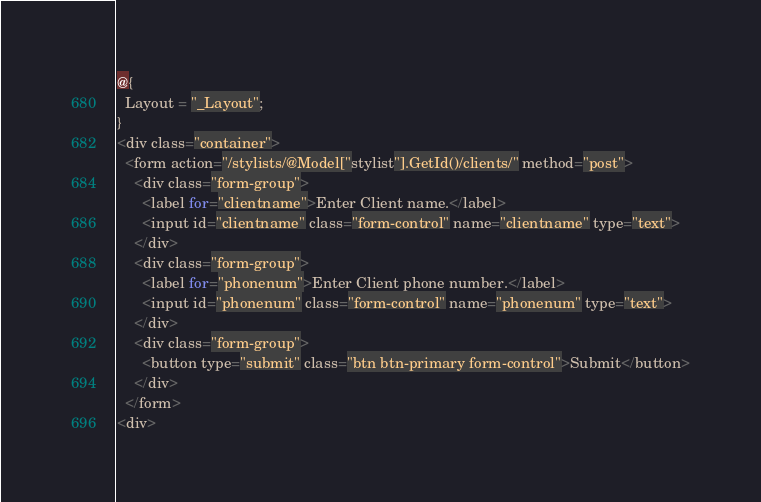<code> <loc_0><loc_0><loc_500><loc_500><_C#_>@{
  Layout = "_Layout";
}
<div class="container">
  <form action="/stylists/@Model["stylist"].GetId()/clients/" method="post">
    <div class="form-group">
      <label for="clientname">Enter Client name.</label>
      <input id="clientname" class="form-control" name="clientname" type="text">
    </div>
    <div class="form-group">
      <label for="phonenum">Enter Client phone number.</label>
      <input id="phonenum" class="form-control" name="phonenum" type="text">
    </div>
    <div class="form-group">
      <button type="submit" class="btn btn-primary form-control">Submit</button>
    </div>
  </form>
<div>
</code> 